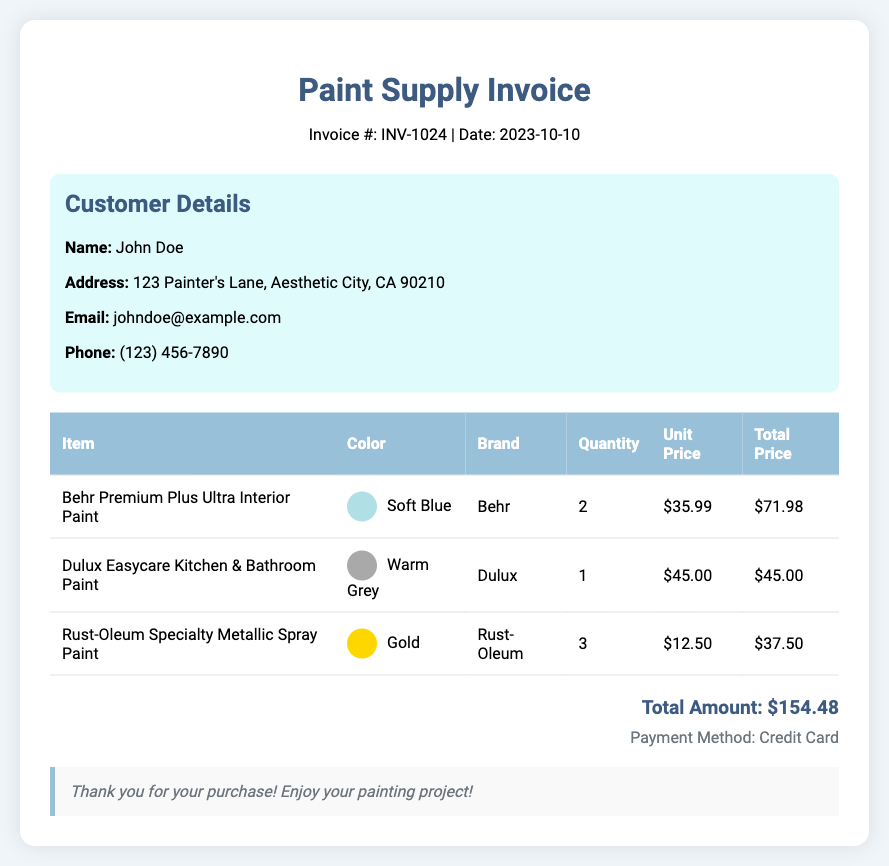What is the invoice number? The invoice number is specified in the header section of the document.
Answer: INV-1024 What is the date of the invoice? The date is provided alongside the invoice number in the header.
Answer: 2023-10-10 What is the name of the customer? The customer's name is given in the customer information section.
Answer: John Doe How many items were purchased? The number of items can be determined by counting the rows in the items table.
Answer: 3 What color is associated with the Behr paint? The color associated with the Behr paint is listed in the items table under the color column.
Answer: Soft Blue What is the total amount charged? The total amount is clearly stated at the bottom of the document.
Answer: $154.48 Which brand is represented by the warm grey paint? The brand information for each paint is detailed in the items table, which mentions the corresponding brand for the paint color.
Answer: Dulux What payment method was used? The payment method is indicated in the payment method section of the document.
Answer: Credit Card How many cans of Rust-Oleum paint were bought? The quantity for each item is included in the items table, specifically for the Rust-Oleum paint.
Answer: 3 